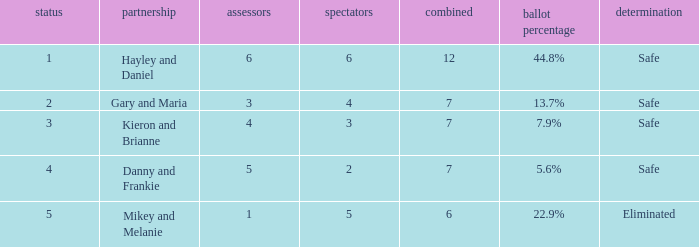How many judges were there for the eliminated couple?  1.0. 